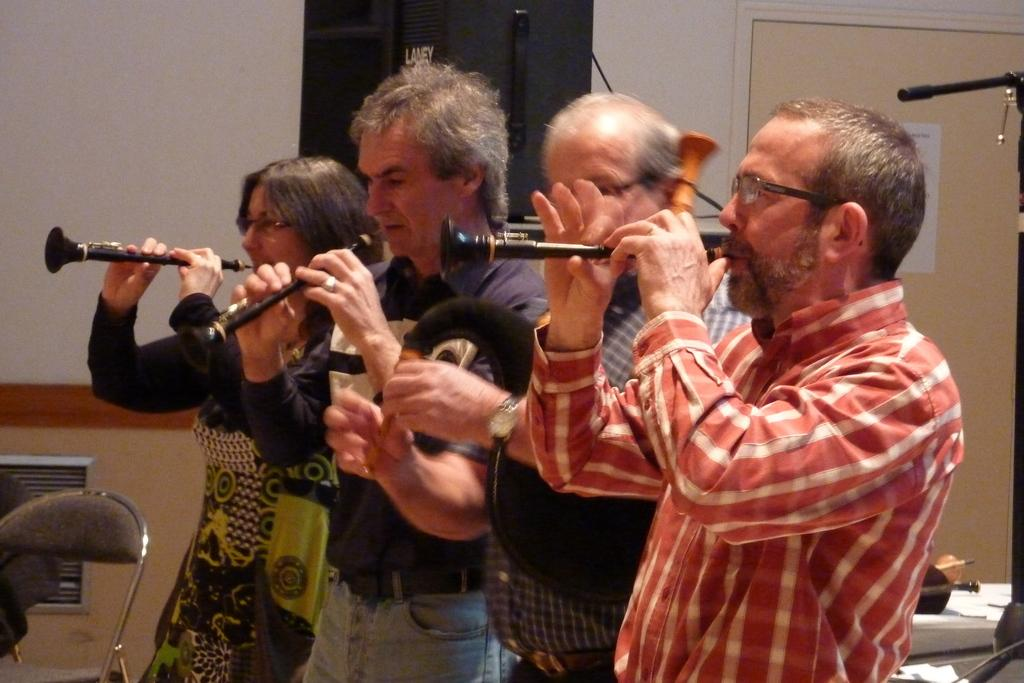How many people are in the image? There are four persons in the image. What are the persons doing in the image? The persons are playing clarinets. What can be seen on the right side of the image? There is a door on the right side of the image. What is located on the left side of the image? There is a chair on the left side of the image. What type of sponge can be seen on the clarinet in the image? There is no sponge present on the clarinets in the image. Can you tell me how many squirrels are playing the clarinets in the image? There are no squirrels present in the image; the persons playing the clarinets are human. 